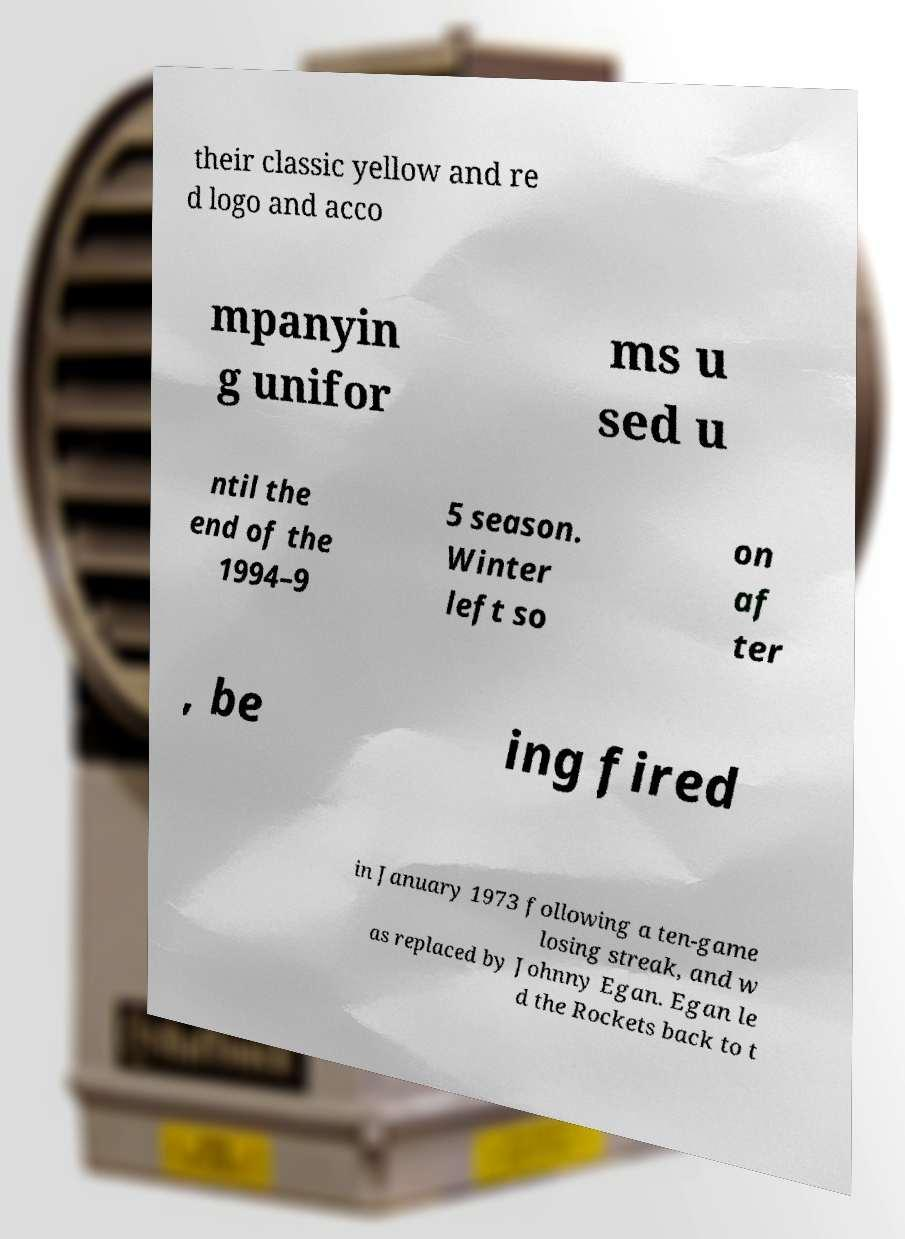Please identify and transcribe the text found in this image. their classic yellow and re d logo and acco mpanyin g unifor ms u sed u ntil the end of the 1994–9 5 season. Winter left so on af ter , be ing fired in January 1973 following a ten-game losing streak, and w as replaced by Johnny Egan. Egan le d the Rockets back to t 